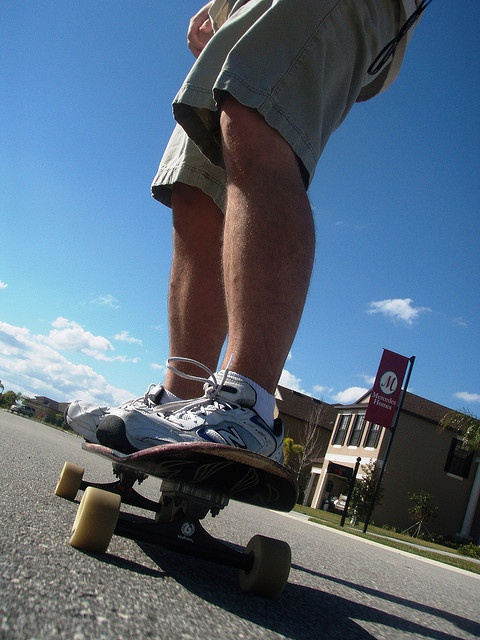Describe the objects in this image and their specific colors. I can see people in gray, black, maroon, and blue tones, skateboard in gray, black, and darkgray tones, and car in gray, black, purple, and darkgray tones in this image. 